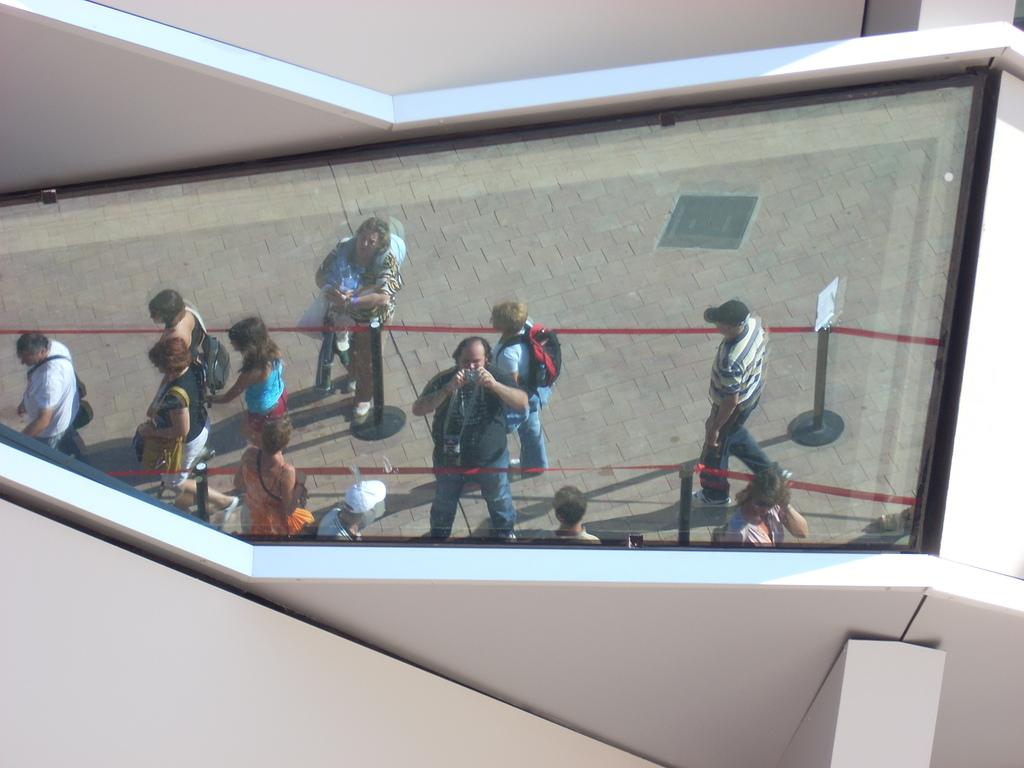What type of structure is present in the image? There is a glass window in the image. What can be seen through the glass window? People are visible through the glass window. What are the barrier rods with a ribbon used for in the image? The barrier rods with a ribbon are used to create a barrier or boundary in the image. What is the path used for in the image? The path is used for people to walk or move through in the image. What type of architectural feature is present in the image? There are walls in the image. Where are the bookshelves located in the image? There are no bookshelves present in the image. What type of apparatus is being used by the people in the image? There is no apparatus being used by the people in the image; they are simply visible through the glass window. 